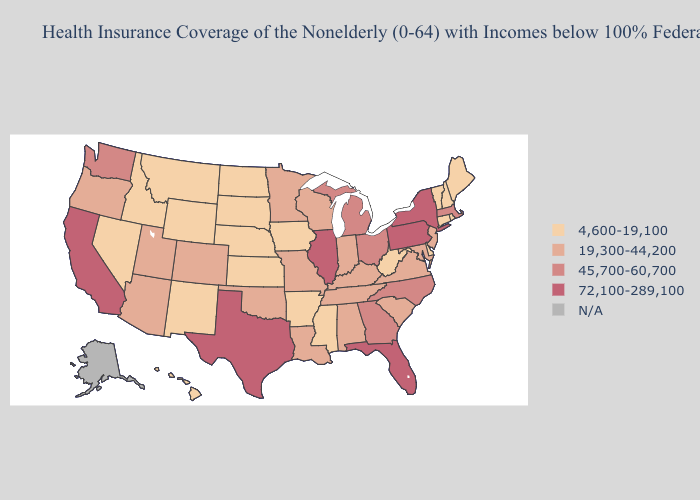Does the map have missing data?
Short answer required. Yes. Among the states that border Louisiana , does Arkansas have the highest value?
Keep it brief. No. Name the states that have a value in the range 45,700-60,700?
Concise answer only. Georgia, Massachusetts, Michigan, North Carolina, Ohio, Washington. Does Illinois have the highest value in the MidWest?
Be succinct. Yes. Name the states that have a value in the range 45,700-60,700?
Quick response, please. Georgia, Massachusetts, Michigan, North Carolina, Ohio, Washington. Does Nevada have the lowest value in the USA?
Be succinct. Yes. Name the states that have a value in the range N/A?
Quick response, please. Alaska. What is the highest value in states that border Ohio?
Concise answer only. 72,100-289,100. Among the states that border New Mexico , which have the highest value?
Quick response, please. Texas. Among the states that border Minnesota , does Iowa have the highest value?
Be succinct. No. What is the highest value in the USA?
Concise answer only. 72,100-289,100. Does Nebraska have the lowest value in the USA?
Be succinct. Yes. Name the states that have a value in the range N/A?
Write a very short answer. Alaska. Does the map have missing data?
Answer briefly. Yes. 